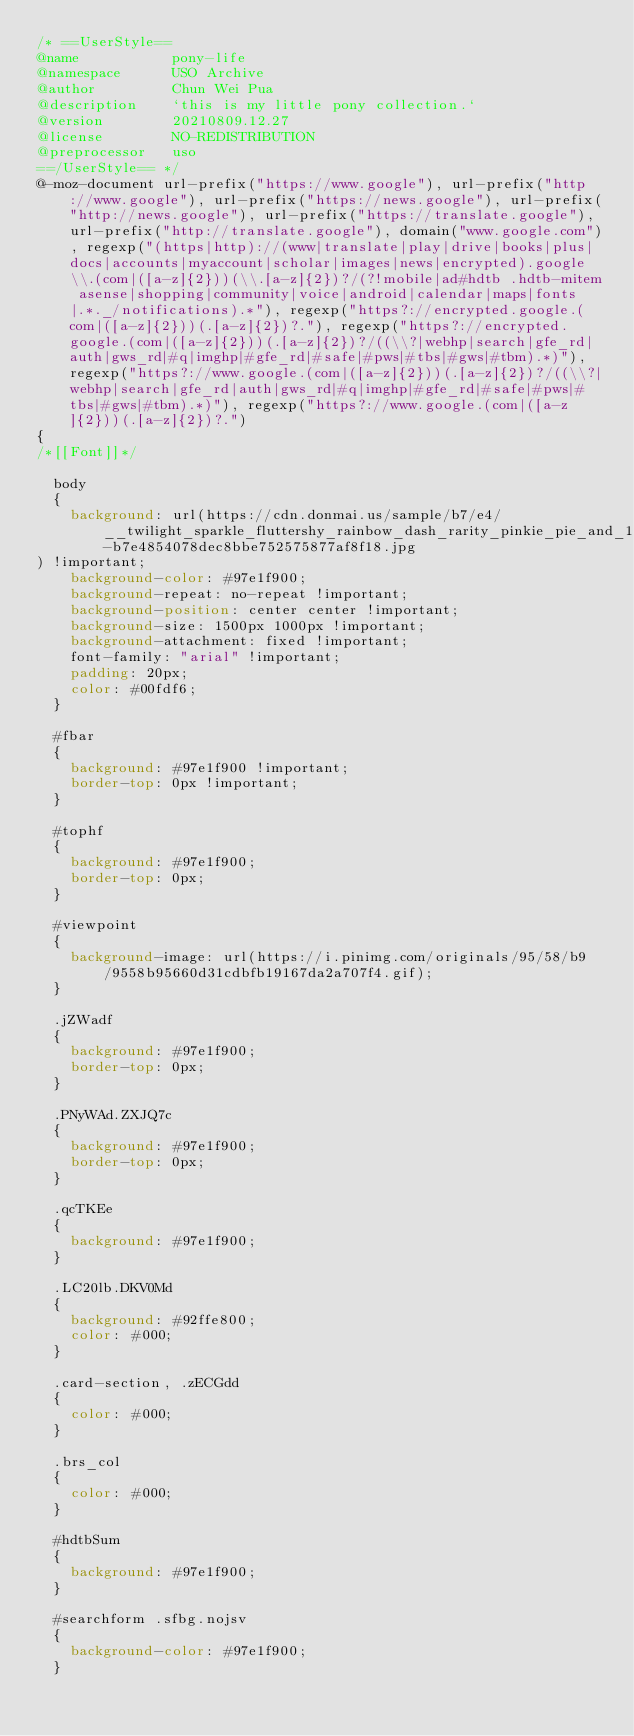Convert code to text. <code><loc_0><loc_0><loc_500><loc_500><_CSS_>/* ==UserStyle==
@name           pony-life
@namespace      USO Archive
@author         Chun Wei Pua
@description    `this is my little pony collection.`
@version        20210809.12.27
@license        NO-REDISTRIBUTION
@preprocessor   uso
==/UserStyle== */
@-moz-document url-prefix("https://www.google"), url-prefix("http://www.google"), url-prefix("https://news.google"), url-prefix("http://news.google"), url-prefix("https://translate.google"), url-prefix("http://translate.google"), domain("www.google.com"), regexp("(https|http)://(www|translate|play|drive|books|plus|docs|accounts|myaccount|scholar|images|news|encrypted).google\\.(com|([a-z]{2}))(\\.[a-z]{2})?/(?!mobile|ad#hdtb .hdtb-mitem asense|shopping|community|voice|android|calendar|maps|fonts|.*._/notifications).*"), regexp("https?://encrypted.google.(com|([a-z]{2}))(.[a-z]{2})?."), regexp("https?://encrypted.google.(com|([a-z]{2}))(.[a-z]{2})?/((\\?|webhp|search|gfe_rd|auth|gws_rd|#q|imghp|#gfe_rd|#safe|#pws|#tbs|#gws|#tbm).*)"), regexp("https?://www.google.(com|([a-z]{2}))(.[a-z]{2})?/((\\?|webhp|search|gfe_rd|auth|gws_rd|#q|imghp|#gfe_rd|#safe|#pws|#tbs|#gws|#tbm).*)"), regexp("https?://www.google.(com|([a-z]{2}))(.[a-z]{2})?.")
{
/*[[Font]]*/

  body
  {
    background: url(https://cdn.donmai.us/sample/b7/e4/__twilight_sparkle_fluttershy_rainbow_dash_rarity_pinkie_pie_and_1_more_my_little_pony_and_3_more_drawn_by_yamashita_shun_ya__sample-b7e4854078dec8bbe752575877af8f18.jpg
) !important;
    background-color: #97e1f900;
    background-repeat: no-repeat !important;
    background-position: center center !important;
    background-size: 1500px 1000px !important;
    background-attachment: fixed !important;
    font-family: "arial" !important;
    padding: 20px;
    color: #00fdf6;
  }

  #fbar
  {
    background: #97e1f900 !important;
    border-top: 0px !important;
  }

  #tophf
  {
    background: #97e1f900;
    border-top: 0px;
  }

  #viewpoint
  {
    background-image: url(https://i.pinimg.com/originals/95/58/b9/9558b95660d31cdbfb19167da2a707f4.gif);
  }

  .jZWadf
  {
    background: #97e1f900;
    border-top: 0px;
  }

  .PNyWAd.ZXJQ7c
  {
    background: #97e1f900;
    border-top: 0px;
  }

  .qcTKEe
  {
    background: #97e1f900;
  }

  .LC20lb.DKV0Md
  {
    background: #92ffe800;
    color: #000;
  }

  .card-section, .zECGdd
  {
    color: #000;
  }

  .brs_col
  {
    color: #000;
  }

  #hdtbSum
  {
    background: #97e1f900;
  }

  #searchform .sfbg.nojsv
  {
    background-color: #97e1f900;
  }</code> 